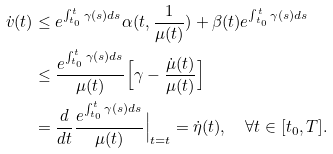<formula> <loc_0><loc_0><loc_500><loc_500>\dot { v } ( t ) & \leq e ^ { \int _ { t _ { 0 } } ^ { t } \gamma ( s ) d s } \alpha ( t , \frac { 1 } { \mu ( t ) } ) + \beta ( t ) e ^ { \int _ { t _ { 0 } } ^ { t } \gamma ( s ) d s } \\ & \leq \frac { e ^ { \int _ { t _ { 0 } } ^ { t } \gamma ( s ) d s } } { \mu ( t ) } \Big { [ } \gamma - \frac { \dot { \mu } ( t ) } { \mu ( t ) } \Big { ] } \\ & = \frac { d } { d t } \frac { e ^ { \int _ { t _ { 0 } } ^ { t } \gamma ( s ) d s } } { \mu ( t ) } \Big { | } _ { t = t } = \dot { \eta } ( t ) , \quad \forall t \in [ t _ { 0 } , T ] .</formula> 